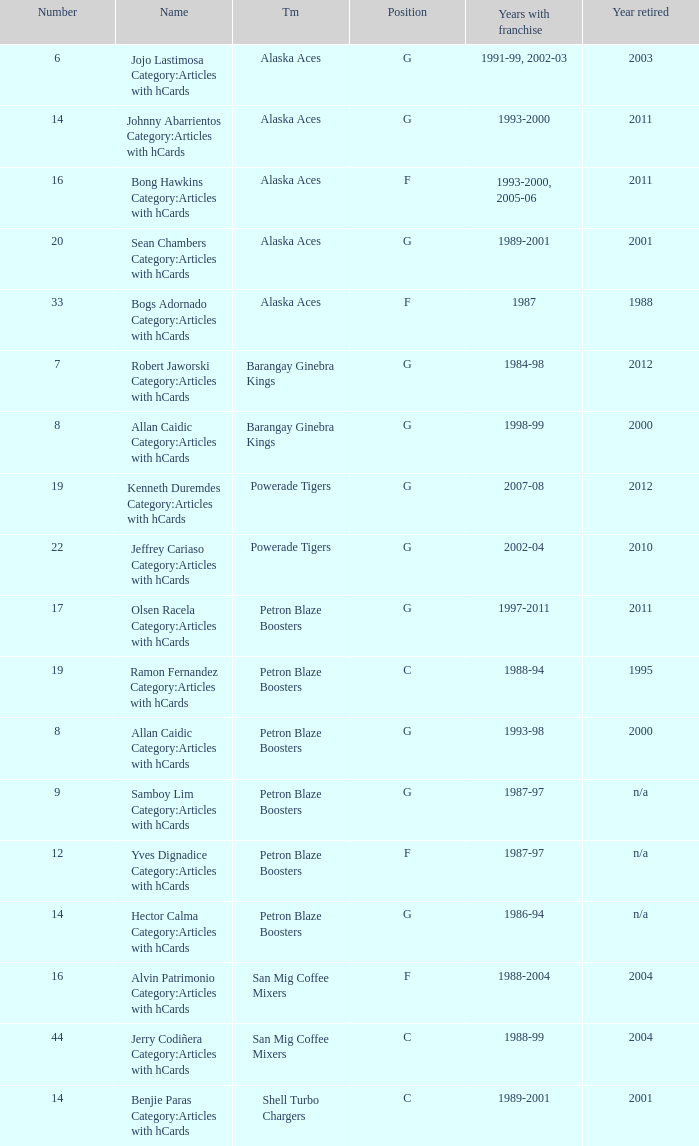Who was the player in Position G on the Petron Blaze Boosters and retired in 2000? Allan Caidic Category:Articles with hCards. 